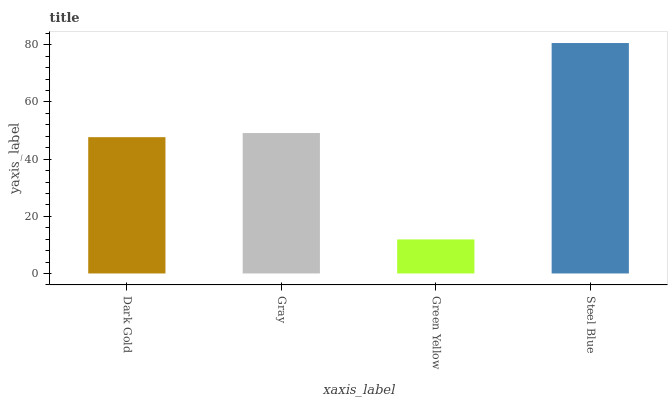Is Green Yellow the minimum?
Answer yes or no. Yes. Is Steel Blue the maximum?
Answer yes or no. Yes. Is Gray the minimum?
Answer yes or no. No. Is Gray the maximum?
Answer yes or no. No. Is Gray greater than Dark Gold?
Answer yes or no. Yes. Is Dark Gold less than Gray?
Answer yes or no. Yes. Is Dark Gold greater than Gray?
Answer yes or no. No. Is Gray less than Dark Gold?
Answer yes or no. No. Is Gray the high median?
Answer yes or no. Yes. Is Dark Gold the low median?
Answer yes or no. Yes. Is Steel Blue the high median?
Answer yes or no. No. Is Green Yellow the low median?
Answer yes or no. No. 